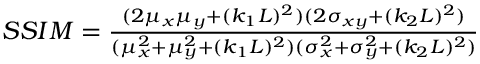Convert formula to latex. <formula><loc_0><loc_0><loc_500><loc_500>\begin{array} { r } { S S I M = \frac { ( 2 \mu _ { x } \mu _ { y } + ( k _ { 1 } L ) ^ { 2 } ) ( 2 \sigma _ { x y } + ( k _ { 2 } L ) ^ { 2 } ) } { ( \mu _ { x } ^ { 2 } + \mu _ { y } ^ { 2 } + ( k _ { 1 } L ) ^ { 2 } ) ( \sigma _ { x } ^ { 2 } + \sigma _ { y } ^ { 2 } + ( k _ { 2 } L ) ^ { 2 } ) } } \end{array}</formula> 